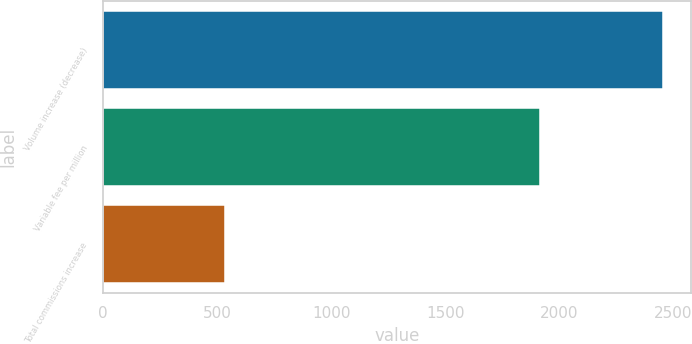Convert chart. <chart><loc_0><loc_0><loc_500><loc_500><bar_chart><fcel>Volume increase (decrease)<fcel>Variable fee per million<fcel>Total commissions increase<nl><fcel>2452<fcel>1917<fcel>535<nl></chart> 